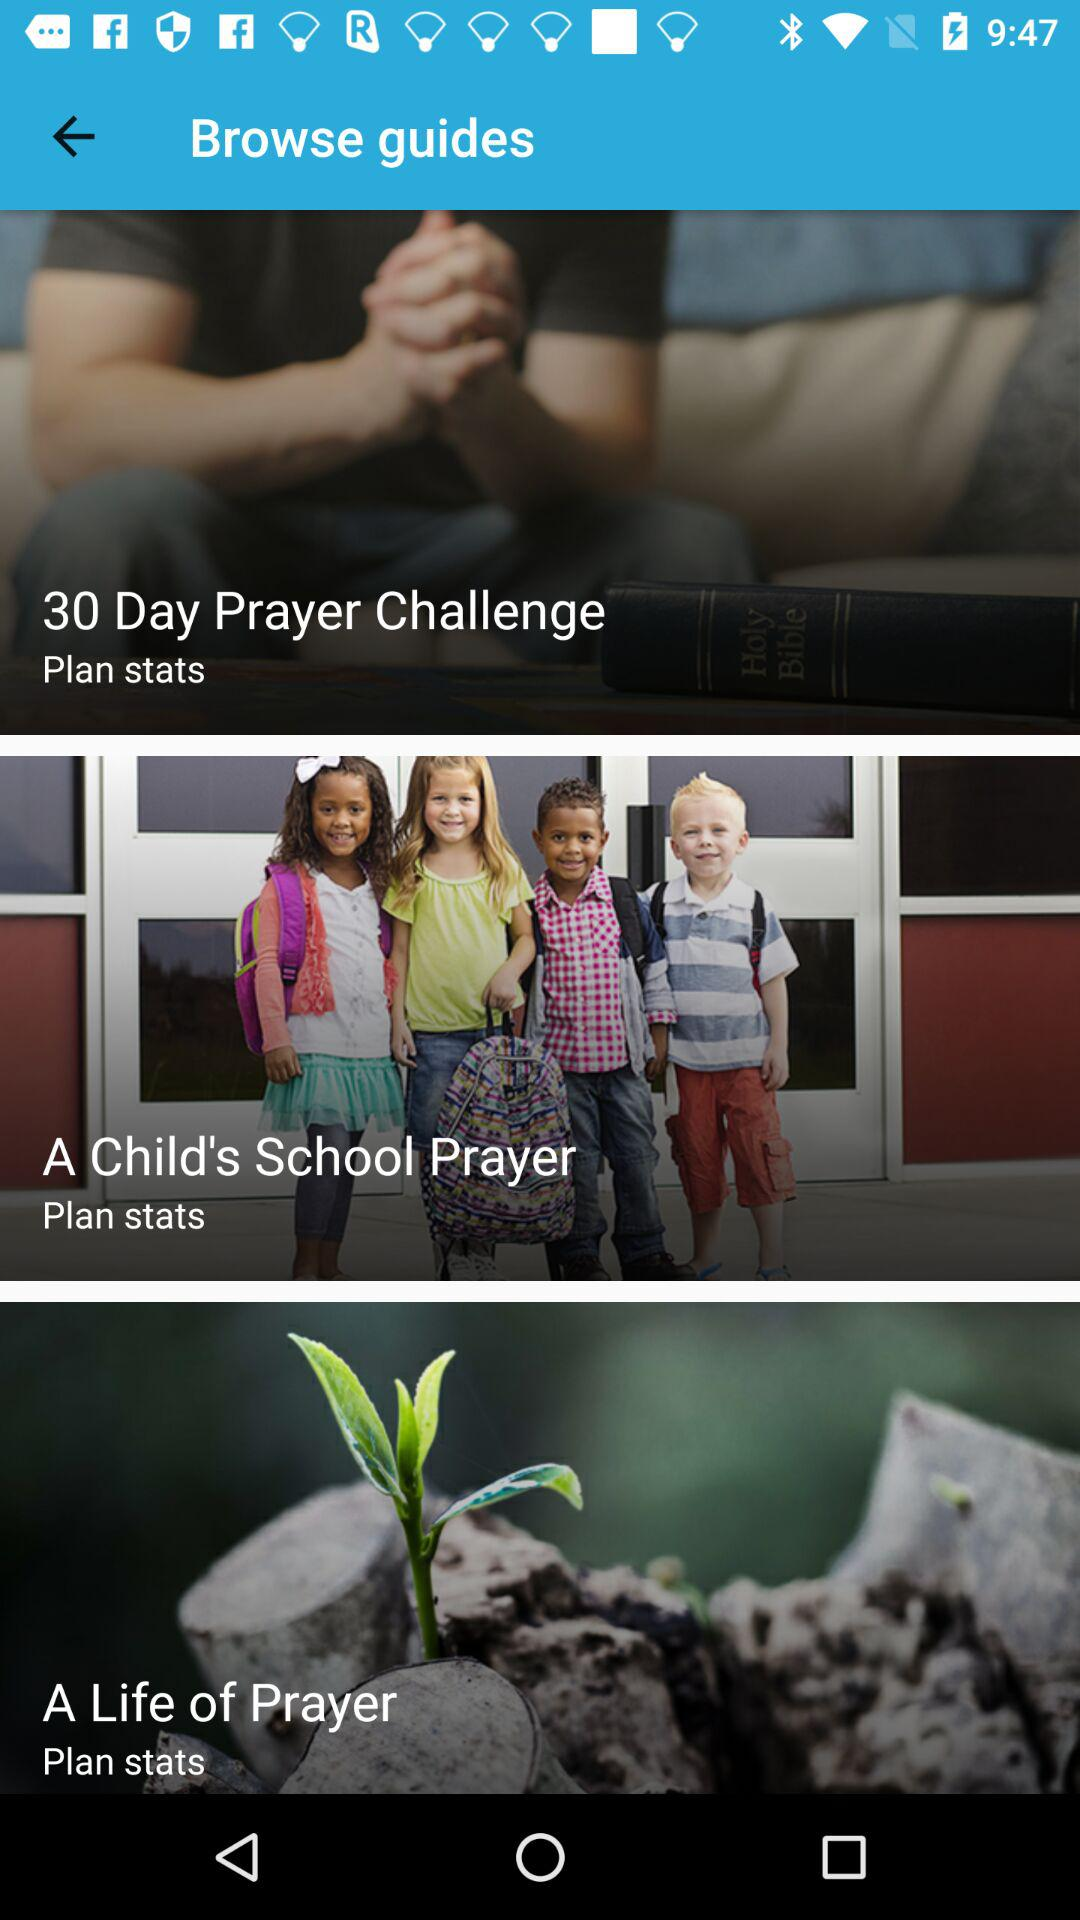How many guides have stats?
Answer the question using a single word or phrase. 3 